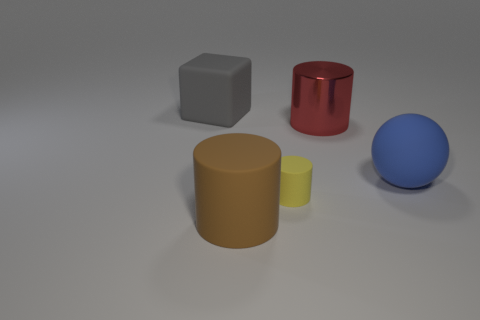How many other things are the same size as the brown rubber object?
Your answer should be very brief. 3. What number of other objects are there of the same color as the small thing?
Keep it short and to the point. 0. Is there any other thing that is the same size as the blue matte thing?
Keep it short and to the point. Yes. What number of other things are the same shape as the blue matte object?
Provide a short and direct response. 0. Do the gray object and the red cylinder have the same size?
Your response must be concise. Yes. Are there any large gray rubber things?
Give a very brief answer. Yes. Is there any other thing that has the same material as the big red object?
Provide a succinct answer. No. Is there another large object made of the same material as the big blue object?
Provide a short and direct response. Yes. What is the material of the gray block that is the same size as the ball?
Provide a short and direct response. Rubber. What number of other big shiny objects have the same shape as the brown object?
Your answer should be compact. 1. 